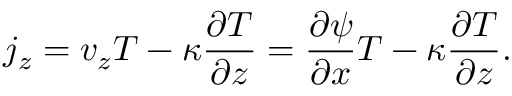<formula> <loc_0><loc_0><loc_500><loc_500>j _ { z } = v _ { z } T - \kappa \frac { \partial T } { \partial z } = \frac { \partial \psi } { \partial x } T - \kappa \frac { \partial T } { \partial z } .</formula> 